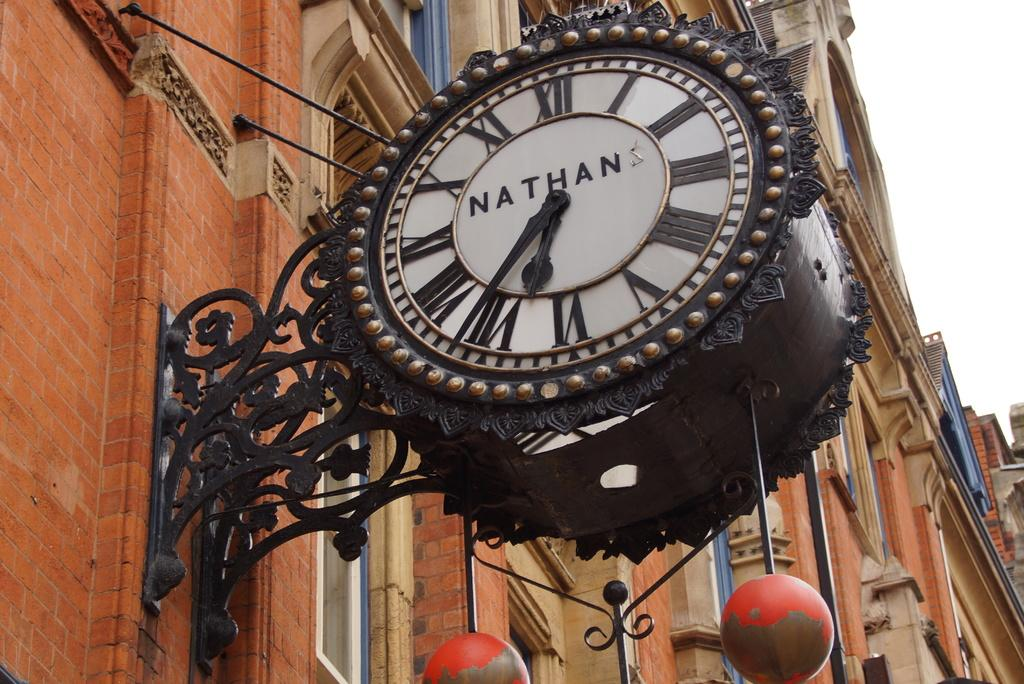Provide a one-sentence caption for the provided image. Circule clock hanging outdoors and says NATHAN on the face. 